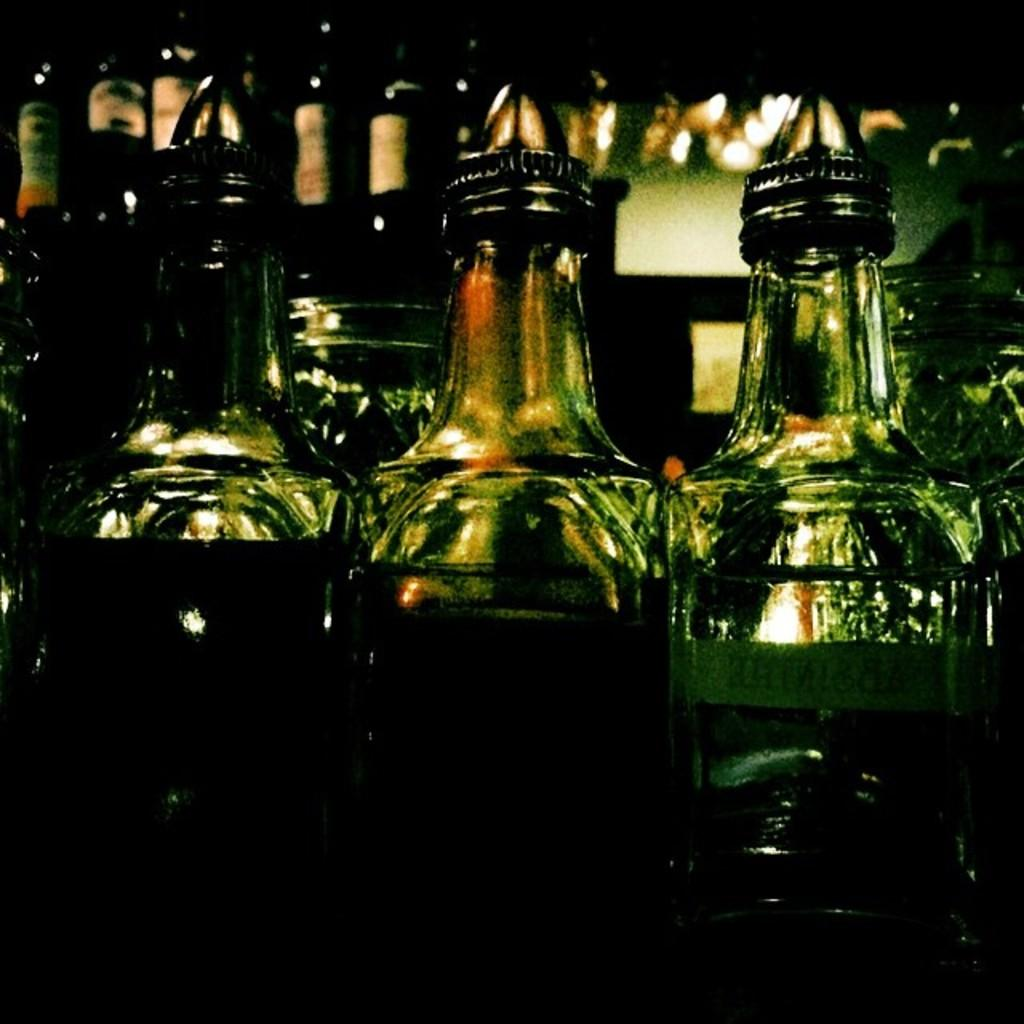What objects are present in large quantities in the image? There are many bottles in the image. What is inside the bottles? The bottles contain liquid. How much sand can be seen in the image? There is no sand present in the image; it features many bottles containing liquid. 